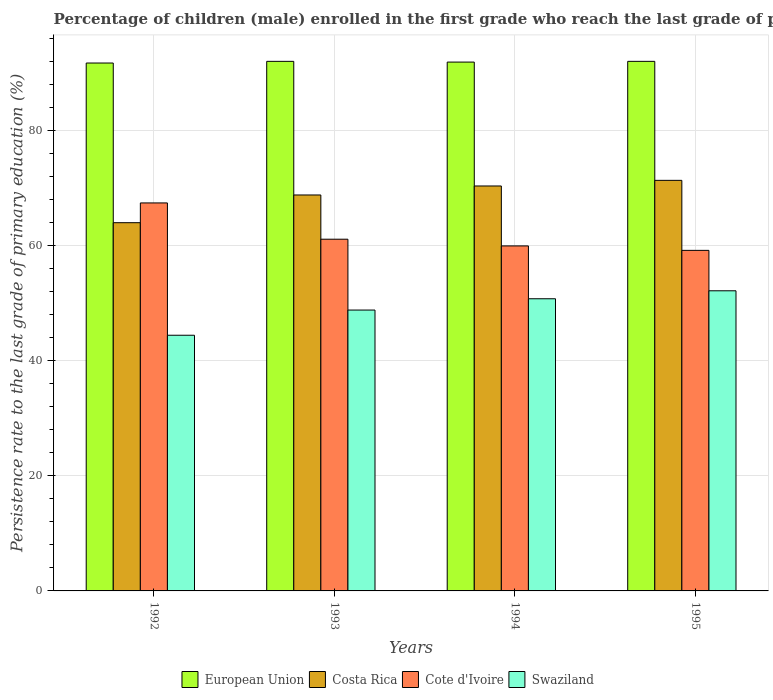How many groups of bars are there?
Offer a very short reply. 4. Are the number of bars per tick equal to the number of legend labels?
Provide a short and direct response. Yes. Are the number of bars on each tick of the X-axis equal?
Ensure brevity in your answer.  Yes. How many bars are there on the 4th tick from the right?
Provide a short and direct response. 4. What is the label of the 1st group of bars from the left?
Give a very brief answer. 1992. In how many cases, is the number of bars for a given year not equal to the number of legend labels?
Provide a succinct answer. 0. What is the persistence rate of children in Costa Rica in 1992?
Your answer should be very brief. 63.93. Across all years, what is the maximum persistence rate of children in Costa Rica?
Make the answer very short. 71.29. Across all years, what is the minimum persistence rate of children in Cote d'Ivoire?
Offer a very short reply. 59.13. In which year was the persistence rate of children in Cote d'Ivoire minimum?
Provide a succinct answer. 1995. What is the total persistence rate of children in Costa Rica in the graph?
Offer a very short reply. 274.27. What is the difference between the persistence rate of children in Swaziland in 1992 and that in 1995?
Offer a terse response. -7.72. What is the difference between the persistence rate of children in Cote d'Ivoire in 1992 and the persistence rate of children in European Union in 1994?
Offer a terse response. -24.45. What is the average persistence rate of children in Swaziland per year?
Your answer should be very brief. 49. In the year 1994, what is the difference between the persistence rate of children in European Union and persistence rate of children in Swaziland?
Provide a succinct answer. 41.09. In how many years, is the persistence rate of children in Costa Rica greater than 64 %?
Offer a very short reply. 3. What is the ratio of the persistence rate of children in Costa Rica in 1992 to that in 1993?
Make the answer very short. 0.93. Is the persistence rate of children in Cote d'Ivoire in 1992 less than that in 1993?
Provide a succinct answer. No. What is the difference between the highest and the second highest persistence rate of children in Costa Rica?
Ensure brevity in your answer.  0.98. What is the difference between the highest and the lowest persistence rate of children in European Union?
Offer a terse response. 0.29. In how many years, is the persistence rate of children in Costa Rica greater than the average persistence rate of children in Costa Rica taken over all years?
Your answer should be compact. 3. Is the sum of the persistence rate of children in Costa Rica in 1993 and 1994 greater than the maximum persistence rate of children in Swaziland across all years?
Ensure brevity in your answer.  Yes. Is it the case that in every year, the sum of the persistence rate of children in European Union and persistence rate of children in Swaziland is greater than the sum of persistence rate of children in Cote d'Ivoire and persistence rate of children in Costa Rica?
Keep it short and to the point. Yes. What does the 3rd bar from the left in 1993 represents?
Offer a very short reply. Cote d'Ivoire. Are all the bars in the graph horizontal?
Offer a very short reply. No. What is the difference between two consecutive major ticks on the Y-axis?
Give a very brief answer. 20. Does the graph contain any zero values?
Your response must be concise. No. Where does the legend appear in the graph?
Your answer should be compact. Bottom center. What is the title of the graph?
Offer a terse response. Percentage of children (male) enrolled in the first grade who reach the last grade of primary education. Does "Belarus" appear as one of the legend labels in the graph?
Keep it short and to the point. No. What is the label or title of the X-axis?
Provide a succinct answer. Years. What is the label or title of the Y-axis?
Ensure brevity in your answer.  Persistence rate to the last grade of primary education (%). What is the Persistence rate to the last grade of primary education (%) in European Union in 1992?
Make the answer very short. 91.65. What is the Persistence rate to the last grade of primary education (%) of Costa Rica in 1992?
Your answer should be compact. 63.93. What is the Persistence rate to the last grade of primary education (%) in Cote d'Ivoire in 1992?
Your response must be concise. 67.37. What is the Persistence rate to the last grade of primary education (%) in Swaziland in 1992?
Provide a succinct answer. 44.39. What is the Persistence rate to the last grade of primary education (%) in European Union in 1993?
Give a very brief answer. 91.95. What is the Persistence rate to the last grade of primary education (%) in Costa Rica in 1993?
Your response must be concise. 68.75. What is the Persistence rate to the last grade of primary education (%) of Cote d'Ivoire in 1993?
Make the answer very short. 61.06. What is the Persistence rate to the last grade of primary education (%) in Swaziland in 1993?
Your answer should be very brief. 48.76. What is the Persistence rate to the last grade of primary education (%) of European Union in 1994?
Your answer should be very brief. 91.82. What is the Persistence rate to the last grade of primary education (%) of Costa Rica in 1994?
Give a very brief answer. 70.31. What is the Persistence rate to the last grade of primary education (%) of Cote d'Ivoire in 1994?
Ensure brevity in your answer.  59.9. What is the Persistence rate to the last grade of primary education (%) of Swaziland in 1994?
Keep it short and to the point. 50.73. What is the Persistence rate to the last grade of primary education (%) in European Union in 1995?
Ensure brevity in your answer.  91.94. What is the Persistence rate to the last grade of primary education (%) in Costa Rica in 1995?
Provide a succinct answer. 71.29. What is the Persistence rate to the last grade of primary education (%) of Cote d'Ivoire in 1995?
Your answer should be very brief. 59.13. What is the Persistence rate to the last grade of primary education (%) of Swaziland in 1995?
Your response must be concise. 52.11. Across all years, what is the maximum Persistence rate to the last grade of primary education (%) of European Union?
Give a very brief answer. 91.95. Across all years, what is the maximum Persistence rate to the last grade of primary education (%) in Costa Rica?
Your answer should be compact. 71.29. Across all years, what is the maximum Persistence rate to the last grade of primary education (%) of Cote d'Ivoire?
Offer a terse response. 67.37. Across all years, what is the maximum Persistence rate to the last grade of primary education (%) of Swaziland?
Give a very brief answer. 52.11. Across all years, what is the minimum Persistence rate to the last grade of primary education (%) in European Union?
Your answer should be very brief. 91.65. Across all years, what is the minimum Persistence rate to the last grade of primary education (%) in Costa Rica?
Your answer should be compact. 63.93. Across all years, what is the minimum Persistence rate to the last grade of primary education (%) of Cote d'Ivoire?
Offer a terse response. 59.13. Across all years, what is the minimum Persistence rate to the last grade of primary education (%) of Swaziland?
Keep it short and to the point. 44.39. What is the total Persistence rate to the last grade of primary education (%) in European Union in the graph?
Keep it short and to the point. 367.36. What is the total Persistence rate to the last grade of primary education (%) in Costa Rica in the graph?
Keep it short and to the point. 274.27. What is the total Persistence rate to the last grade of primary education (%) in Cote d'Ivoire in the graph?
Provide a succinct answer. 247.46. What is the total Persistence rate to the last grade of primary education (%) of Swaziland in the graph?
Your answer should be very brief. 195.99. What is the difference between the Persistence rate to the last grade of primary education (%) of European Union in 1992 and that in 1993?
Offer a terse response. -0.29. What is the difference between the Persistence rate to the last grade of primary education (%) in Costa Rica in 1992 and that in 1993?
Keep it short and to the point. -4.81. What is the difference between the Persistence rate to the last grade of primary education (%) of Cote d'Ivoire in 1992 and that in 1993?
Keep it short and to the point. 6.3. What is the difference between the Persistence rate to the last grade of primary education (%) of Swaziland in 1992 and that in 1993?
Keep it short and to the point. -4.37. What is the difference between the Persistence rate to the last grade of primary education (%) of European Union in 1992 and that in 1994?
Provide a succinct answer. -0.16. What is the difference between the Persistence rate to the last grade of primary education (%) of Costa Rica in 1992 and that in 1994?
Provide a succinct answer. -6.37. What is the difference between the Persistence rate to the last grade of primary education (%) of Cote d'Ivoire in 1992 and that in 1994?
Provide a short and direct response. 7.46. What is the difference between the Persistence rate to the last grade of primary education (%) in Swaziland in 1992 and that in 1994?
Your answer should be very brief. -6.34. What is the difference between the Persistence rate to the last grade of primary education (%) of European Union in 1992 and that in 1995?
Your response must be concise. -0.29. What is the difference between the Persistence rate to the last grade of primary education (%) in Costa Rica in 1992 and that in 1995?
Ensure brevity in your answer.  -7.35. What is the difference between the Persistence rate to the last grade of primary education (%) of Cote d'Ivoire in 1992 and that in 1995?
Your answer should be very brief. 8.24. What is the difference between the Persistence rate to the last grade of primary education (%) in Swaziland in 1992 and that in 1995?
Your answer should be very brief. -7.72. What is the difference between the Persistence rate to the last grade of primary education (%) of European Union in 1993 and that in 1994?
Provide a succinct answer. 0.13. What is the difference between the Persistence rate to the last grade of primary education (%) of Costa Rica in 1993 and that in 1994?
Your response must be concise. -1.56. What is the difference between the Persistence rate to the last grade of primary education (%) in Cote d'Ivoire in 1993 and that in 1994?
Offer a very short reply. 1.16. What is the difference between the Persistence rate to the last grade of primary education (%) in Swaziland in 1993 and that in 1994?
Your response must be concise. -1.96. What is the difference between the Persistence rate to the last grade of primary education (%) of European Union in 1993 and that in 1995?
Your answer should be compact. 0. What is the difference between the Persistence rate to the last grade of primary education (%) in Costa Rica in 1993 and that in 1995?
Your response must be concise. -2.54. What is the difference between the Persistence rate to the last grade of primary education (%) of Cote d'Ivoire in 1993 and that in 1995?
Your answer should be very brief. 1.94. What is the difference between the Persistence rate to the last grade of primary education (%) of Swaziland in 1993 and that in 1995?
Ensure brevity in your answer.  -3.34. What is the difference between the Persistence rate to the last grade of primary education (%) in European Union in 1994 and that in 1995?
Offer a very short reply. -0.13. What is the difference between the Persistence rate to the last grade of primary education (%) of Costa Rica in 1994 and that in 1995?
Keep it short and to the point. -0.98. What is the difference between the Persistence rate to the last grade of primary education (%) in Cote d'Ivoire in 1994 and that in 1995?
Your response must be concise. 0.78. What is the difference between the Persistence rate to the last grade of primary education (%) of Swaziland in 1994 and that in 1995?
Keep it short and to the point. -1.38. What is the difference between the Persistence rate to the last grade of primary education (%) of European Union in 1992 and the Persistence rate to the last grade of primary education (%) of Costa Rica in 1993?
Ensure brevity in your answer.  22.91. What is the difference between the Persistence rate to the last grade of primary education (%) in European Union in 1992 and the Persistence rate to the last grade of primary education (%) in Cote d'Ivoire in 1993?
Offer a terse response. 30.59. What is the difference between the Persistence rate to the last grade of primary education (%) of European Union in 1992 and the Persistence rate to the last grade of primary education (%) of Swaziland in 1993?
Offer a terse response. 42.89. What is the difference between the Persistence rate to the last grade of primary education (%) of Costa Rica in 1992 and the Persistence rate to the last grade of primary education (%) of Cote d'Ivoire in 1993?
Provide a short and direct response. 2.87. What is the difference between the Persistence rate to the last grade of primary education (%) in Costa Rica in 1992 and the Persistence rate to the last grade of primary education (%) in Swaziland in 1993?
Provide a short and direct response. 15.17. What is the difference between the Persistence rate to the last grade of primary education (%) in Cote d'Ivoire in 1992 and the Persistence rate to the last grade of primary education (%) in Swaziland in 1993?
Keep it short and to the point. 18.6. What is the difference between the Persistence rate to the last grade of primary education (%) in European Union in 1992 and the Persistence rate to the last grade of primary education (%) in Costa Rica in 1994?
Provide a short and direct response. 21.35. What is the difference between the Persistence rate to the last grade of primary education (%) of European Union in 1992 and the Persistence rate to the last grade of primary education (%) of Cote d'Ivoire in 1994?
Provide a short and direct response. 31.75. What is the difference between the Persistence rate to the last grade of primary education (%) of European Union in 1992 and the Persistence rate to the last grade of primary education (%) of Swaziland in 1994?
Your answer should be very brief. 40.93. What is the difference between the Persistence rate to the last grade of primary education (%) in Costa Rica in 1992 and the Persistence rate to the last grade of primary education (%) in Cote d'Ivoire in 1994?
Your answer should be very brief. 4.03. What is the difference between the Persistence rate to the last grade of primary education (%) of Costa Rica in 1992 and the Persistence rate to the last grade of primary education (%) of Swaziland in 1994?
Offer a terse response. 13.21. What is the difference between the Persistence rate to the last grade of primary education (%) in Cote d'Ivoire in 1992 and the Persistence rate to the last grade of primary education (%) in Swaziland in 1994?
Your answer should be compact. 16.64. What is the difference between the Persistence rate to the last grade of primary education (%) in European Union in 1992 and the Persistence rate to the last grade of primary education (%) in Costa Rica in 1995?
Your response must be concise. 20.37. What is the difference between the Persistence rate to the last grade of primary education (%) of European Union in 1992 and the Persistence rate to the last grade of primary education (%) of Cote d'Ivoire in 1995?
Make the answer very short. 32.53. What is the difference between the Persistence rate to the last grade of primary education (%) in European Union in 1992 and the Persistence rate to the last grade of primary education (%) in Swaziland in 1995?
Your response must be concise. 39.54. What is the difference between the Persistence rate to the last grade of primary education (%) of Costa Rica in 1992 and the Persistence rate to the last grade of primary education (%) of Cote d'Ivoire in 1995?
Provide a short and direct response. 4.81. What is the difference between the Persistence rate to the last grade of primary education (%) of Costa Rica in 1992 and the Persistence rate to the last grade of primary education (%) of Swaziland in 1995?
Your response must be concise. 11.82. What is the difference between the Persistence rate to the last grade of primary education (%) of Cote d'Ivoire in 1992 and the Persistence rate to the last grade of primary education (%) of Swaziland in 1995?
Provide a short and direct response. 15.26. What is the difference between the Persistence rate to the last grade of primary education (%) of European Union in 1993 and the Persistence rate to the last grade of primary education (%) of Costa Rica in 1994?
Offer a terse response. 21.64. What is the difference between the Persistence rate to the last grade of primary education (%) in European Union in 1993 and the Persistence rate to the last grade of primary education (%) in Cote d'Ivoire in 1994?
Your response must be concise. 32.04. What is the difference between the Persistence rate to the last grade of primary education (%) of European Union in 1993 and the Persistence rate to the last grade of primary education (%) of Swaziland in 1994?
Offer a very short reply. 41.22. What is the difference between the Persistence rate to the last grade of primary education (%) in Costa Rica in 1993 and the Persistence rate to the last grade of primary education (%) in Cote d'Ivoire in 1994?
Your answer should be compact. 8.84. What is the difference between the Persistence rate to the last grade of primary education (%) in Costa Rica in 1993 and the Persistence rate to the last grade of primary education (%) in Swaziland in 1994?
Ensure brevity in your answer.  18.02. What is the difference between the Persistence rate to the last grade of primary education (%) of Cote d'Ivoire in 1993 and the Persistence rate to the last grade of primary education (%) of Swaziland in 1994?
Your response must be concise. 10.34. What is the difference between the Persistence rate to the last grade of primary education (%) in European Union in 1993 and the Persistence rate to the last grade of primary education (%) in Costa Rica in 1995?
Your response must be concise. 20.66. What is the difference between the Persistence rate to the last grade of primary education (%) of European Union in 1993 and the Persistence rate to the last grade of primary education (%) of Cote d'Ivoire in 1995?
Provide a short and direct response. 32.82. What is the difference between the Persistence rate to the last grade of primary education (%) of European Union in 1993 and the Persistence rate to the last grade of primary education (%) of Swaziland in 1995?
Provide a short and direct response. 39.84. What is the difference between the Persistence rate to the last grade of primary education (%) in Costa Rica in 1993 and the Persistence rate to the last grade of primary education (%) in Cote d'Ivoire in 1995?
Your response must be concise. 9.62. What is the difference between the Persistence rate to the last grade of primary education (%) of Costa Rica in 1993 and the Persistence rate to the last grade of primary education (%) of Swaziland in 1995?
Provide a short and direct response. 16.64. What is the difference between the Persistence rate to the last grade of primary education (%) in Cote d'Ivoire in 1993 and the Persistence rate to the last grade of primary education (%) in Swaziland in 1995?
Make the answer very short. 8.95. What is the difference between the Persistence rate to the last grade of primary education (%) in European Union in 1994 and the Persistence rate to the last grade of primary education (%) in Costa Rica in 1995?
Your response must be concise. 20.53. What is the difference between the Persistence rate to the last grade of primary education (%) of European Union in 1994 and the Persistence rate to the last grade of primary education (%) of Cote d'Ivoire in 1995?
Your answer should be compact. 32.69. What is the difference between the Persistence rate to the last grade of primary education (%) of European Union in 1994 and the Persistence rate to the last grade of primary education (%) of Swaziland in 1995?
Your response must be concise. 39.71. What is the difference between the Persistence rate to the last grade of primary education (%) in Costa Rica in 1994 and the Persistence rate to the last grade of primary education (%) in Cote d'Ivoire in 1995?
Make the answer very short. 11.18. What is the difference between the Persistence rate to the last grade of primary education (%) in Costa Rica in 1994 and the Persistence rate to the last grade of primary education (%) in Swaziland in 1995?
Give a very brief answer. 18.2. What is the difference between the Persistence rate to the last grade of primary education (%) of Cote d'Ivoire in 1994 and the Persistence rate to the last grade of primary education (%) of Swaziland in 1995?
Your answer should be very brief. 7.79. What is the average Persistence rate to the last grade of primary education (%) in European Union per year?
Provide a short and direct response. 91.84. What is the average Persistence rate to the last grade of primary education (%) of Costa Rica per year?
Your response must be concise. 68.57. What is the average Persistence rate to the last grade of primary education (%) of Cote d'Ivoire per year?
Your answer should be very brief. 61.87. What is the average Persistence rate to the last grade of primary education (%) in Swaziland per year?
Your answer should be compact. 49. In the year 1992, what is the difference between the Persistence rate to the last grade of primary education (%) of European Union and Persistence rate to the last grade of primary education (%) of Costa Rica?
Provide a short and direct response. 27.72. In the year 1992, what is the difference between the Persistence rate to the last grade of primary education (%) in European Union and Persistence rate to the last grade of primary education (%) in Cote d'Ivoire?
Provide a succinct answer. 24.29. In the year 1992, what is the difference between the Persistence rate to the last grade of primary education (%) of European Union and Persistence rate to the last grade of primary education (%) of Swaziland?
Provide a succinct answer. 47.26. In the year 1992, what is the difference between the Persistence rate to the last grade of primary education (%) in Costa Rica and Persistence rate to the last grade of primary education (%) in Cote d'Ivoire?
Ensure brevity in your answer.  -3.43. In the year 1992, what is the difference between the Persistence rate to the last grade of primary education (%) of Costa Rica and Persistence rate to the last grade of primary education (%) of Swaziland?
Provide a succinct answer. 19.54. In the year 1992, what is the difference between the Persistence rate to the last grade of primary education (%) in Cote d'Ivoire and Persistence rate to the last grade of primary education (%) in Swaziland?
Your answer should be compact. 22.98. In the year 1993, what is the difference between the Persistence rate to the last grade of primary education (%) of European Union and Persistence rate to the last grade of primary education (%) of Costa Rica?
Give a very brief answer. 23.2. In the year 1993, what is the difference between the Persistence rate to the last grade of primary education (%) in European Union and Persistence rate to the last grade of primary education (%) in Cote d'Ivoire?
Make the answer very short. 30.88. In the year 1993, what is the difference between the Persistence rate to the last grade of primary education (%) of European Union and Persistence rate to the last grade of primary education (%) of Swaziland?
Ensure brevity in your answer.  43.18. In the year 1993, what is the difference between the Persistence rate to the last grade of primary education (%) of Costa Rica and Persistence rate to the last grade of primary education (%) of Cote d'Ivoire?
Keep it short and to the point. 7.68. In the year 1993, what is the difference between the Persistence rate to the last grade of primary education (%) of Costa Rica and Persistence rate to the last grade of primary education (%) of Swaziland?
Give a very brief answer. 19.98. In the year 1993, what is the difference between the Persistence rate to the last grade of primary education (%) in Cote d'Ivoire and Persistence rate to the last grade of primary education (%) in Swaziland?
Offer a very short reply. 12.3. In the year 1994, what is the difference between the Persistence rate to the last grade of primary education (%) in European Union and Persistence rate to the last grade of primary education (%) in Costa Rica?
Offer a terse response. 21.51. In the year 1994, what is the difference between the Persistence rate to the last grade of primary education (%) of European Union and Persistence rate to the last grade of primary education (%) of Cote d'Ivoire?
Provide a short and direct response. 31.92. In the year 1994, what is the difference between the Persistence rate to the last grade of primary education (%) of European Union and Persistence rate to the last grade of primary education (%) of Swaziland?
Provide a succinct answer. 41.09. In the year 1994, what is the difference between the Persistence rate to the last grade of primary education (%) of Costa Rica and Persistence rate to the last grade of primary education (%) of Cote d'Ivoire?
Your response must be concise. 10.4. In the year 1994, what is the difference between the Persistence rate to the last grade of primary education (%) of Costa Rica and Persistence rate to the last grade of primary education (%) of Swaziland?
Offer a very short reply. 19.58. In the year 1994, what is the difference between the Persistence rate to the last grade of primary education (%) in Cote d'Ivoire and Persistence rate to the last grade of primary education (%) in Swaziland?
Give a very brief answer. 9.17. In the year 1995, what is the difference between the Persistence rate to the last grade of primary education (%) in European Union and Persistence rate to the last grade of primary education (%) in Costa Rica?
Your answer should be compact. 20.66. In the year 1995, what is the difference between the Persistence rate to the last grade of primary education (%) of European Union and Persistence rate to the last grade of primary education (%) of Cote d'Ivoire?
Give a very brief answer. 32.82. In the year 1995, what is the difference between the Persistence rate to the last grade of primary education (%) in European Union and Persistence rate to the last grade of primary education (%) in Swaziland?
Ensure brevity in your answer.  39.83. In the year 1995, what is the difference between the Persistence rate to the last grade of primary education (%) of Costa Rica and Persistence rate to the last grade of primary education (%) of Cote d'Ivoire?
Offer a very short reply. 12.16. In the year 1995, what is the difference between the Persistence rate to the last grade of primary education (%) of Costa Rica and Persistence rate to the last grade of primary education (%) of Swaziland?
Provide a short and direct response. 19.18. In the year 1995, what is the difference between the Persistence rate to the last grade of primary education (%) of Cote d'Ivoire and Persistence rate to the last grade of primary education (%) of Swaziland?
Offer a terse response. 7.02. What is the ratio of the Persistence rate to the last grade of primary education (%) of European Union in 1992 to that in 1993?
Your response must be concise. 1. What is the ratio of the Persistence rate to the last grade of primary education (%) in Costa Rica in 1992 to that in 1993?
Your answer should be compact. 0.93. What is the ratio of the Persistence rate to the last grade of primary education (%) in Cote d'Ivoire in 1992 to that in 1993?
Keep it short and to the point. 1.1. What is the ratio of the Persistence rate to the last grade of primary education (%) of Swaziland in 1992 to that in 1993?
Provide a short and direct response. 0.91. What is the ratio of the Persistence rate to the last grade of primary education (%) in Costa Rica in 1992 to that in 1994?
Keep it short and to the point. 0.91. What is the ratio of the Persistence rate to the last grade of primary education (%) of Cote d'Ivoire in 1992 to that in 1994?
Ensure brevity in your answer.  1.12. What is the ratio of the Persistence rate to the last grade of primary education (%) in Swaziland in 1992 to that in 1994?
Offer a very short reply. 0.88. What is the ratio of the Persistence rate to the last grade of primary education (%) in Costa Rica in 1992 to that in 1995?
Give a very brief answer. 0.9. What is the ratio of the Persistence rate to the last grade of primary education (%) of Cote d'Ivoire in 1992 to that in 1995?
Provide a succinct answer. 1.14. What is the ratio of the Persistence rate to the last grade of primary education (%) in Swaziland in 1992 to that in 1995?
Your response must be concise. 0.85. What is the ratio of the Persistence rate to the last grade of primary education (%) in Costa Rica in 1993 to that in 1994?
Offer a very short reply. 0.98. What is the ratio of the Persistence rate to the last grade of primary education (%) in Cote d'Ivoire in 1993 to that in 1994?
Keep it short and to the point. 1.02. What is the ratio of the Persistence rate to the last grade of primary education (%) of Swaziland in 1993 to that in 1994?
Your response must be concise. 0.96. What is the ratio of the Persistence rate to the last grade of primary education (%) of Costa Rica in 1993 to that in 1995?
Your answer should be compact. 0.96. What is the ratio of the Persistence rate to the last grade of primary education (%) in Cote d'Ivoire in 1993 to that in 1995?
Offer a terse response. 1.03. What is the ratio of the Persistence rate to the last grade of primary education (%) of Swaziland in 1993 to that in 1995?
Keep it short and to the point. 0.94. What is the ratio of the Persistence rate to the last grade of primary education (%) in Costa Rica in 1994 to that in 1995?
Give a very brief answer. 0.99. What is the ratio of the Persistence rate to the last grade of primary education (%) in Cote d'Ivoire in 1994 to that in 1995?
Make the answer very short. 1.01. What is the ratio of the Persistence rate to the last grade of primary education (%) in Swaziland in 1994 to that in 1995?
Make the answer very short. 0.97. What is the difference between the highest and the second highest Persistence rate to the last grade of primary education (%) of European Union?
Offer a terse response. 0. What is the difference between the highest and the second highest Persistence rate to the last grade of primary education (%) of Costa Rica?
Provide a succinct answer. 0.98. What is the difference between the highest and the second highest Persistence rate to the last grade of primary education (%) of Cote d'Ivoire?
Your response must be concise. 6.3. What is the difference between the highest and the second highest Persistence rate to the last grade of primary education (%) in Swaziland?
Provide a short and direct response. 1.38. What is the difference between the highest and the lowest Persistence rate to the last grade of primary education (%) of European Union?
Ensure brevity in your answer.  0.29. What is the difference between the highest and the lowest Persistence rate to the last grade of primary education (%) in Costa Rica?
Your answer should be very brief. 7.35. What is the difference between the highest and the lowest Persistence rate to the last grade of primary education (%) in Cote d'Ivoire?
Your answer should be compact. 8.24. What is the difference between the highest and the lowest Persistence rate to the last grade of primary education (%) in Swaziland?
Your answer should be very brief. 7.72. 